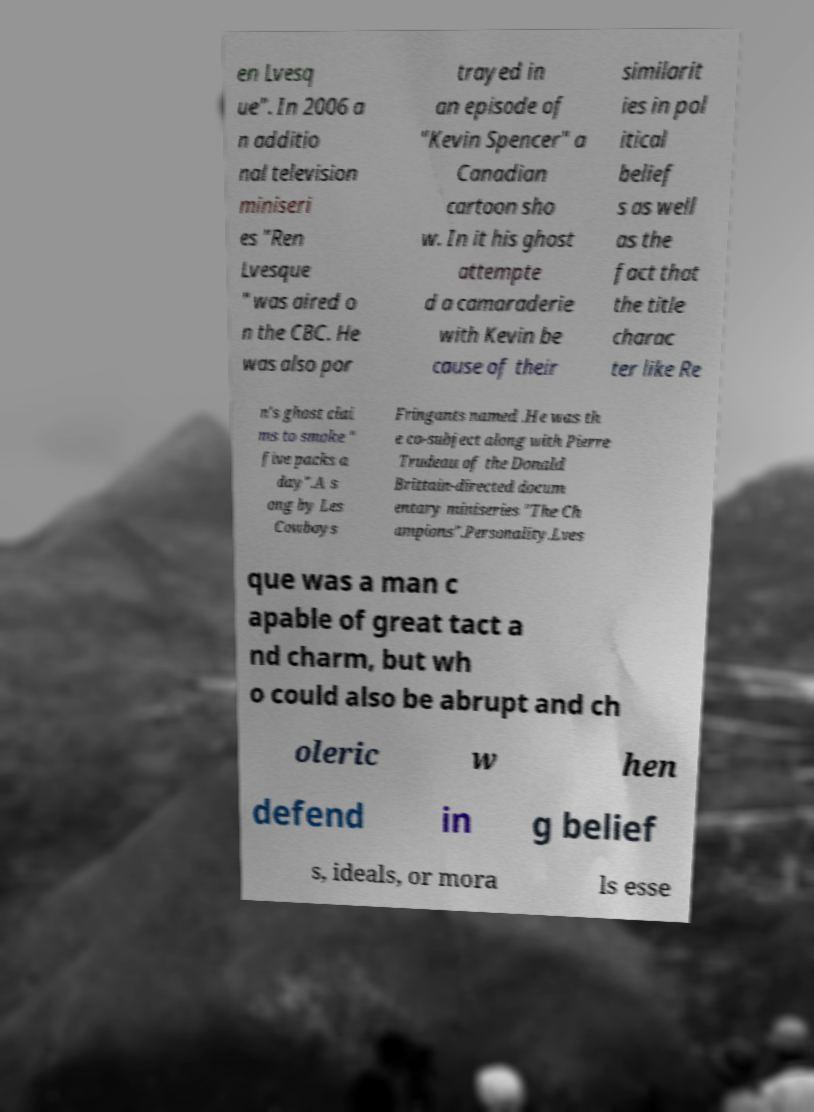Can you read and provide the text displayed in the image?This photo seems to have some interesting text. Can you extract and type it out for me? en Lvesq ue". In 2006 a n additio nal television miniseri es "Ren Lvesque " was aired o n the CBC. He was also por trayed in an episode of "Kevin Spencer" a Canadian cartoon sho w. In it his ghost attempte d a camaraderie with Kevin be cause of their similarit ies in pol itical belief s as well as the fact that the title charac ter like Re n's ghost clai ms to smoke " five packs a day".A s ong by Les Cowboys Fringants named .He was th e co-subject along with Pierre Trudeau of the Donald Brittain-directed docum entary miniseries "The Ch ampions".Personality.Lves que was a man c apable of great tact a nd charm, but wh o could also be abrupt and ch oleric w hen defend in g belief s, ideals, or mora ls esse 